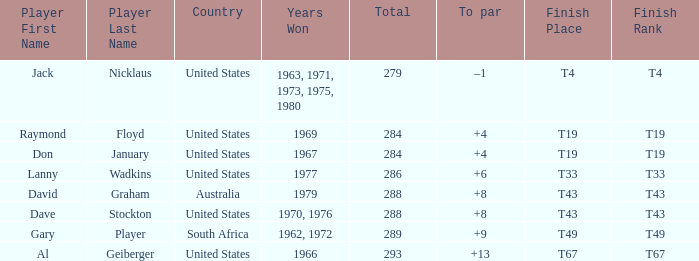Who won in 1979 with +8 to par? David Graham. 